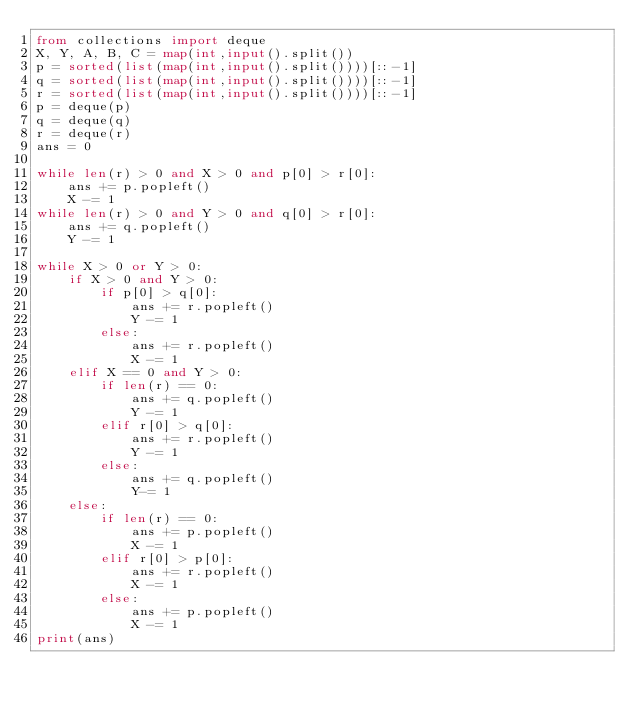Convert code to text. <code><loc_0><loc_0><loc_500><loc_500><_Python_>from collections import deque
X, Y, A, B, C = map(int,input().split())
p = sorted(list(map(int,input().split())))[::-1]
q = sorted(list(map(int,input().split())))[::-1]
r = sorted(list(map(int,input().split())))[::-1]
p = deque(p)
q = deque(q)
r = deque(r)
ans = 0

while len(r) > 0 and X > 0 and p[0] > r[0]:
    ans += p.popleft()
    X -= 1
while len(r) > 0 and Y > 0 and q[0] > r[0]:
    ans += q.popleft()
    Y -= 1

while X > 0 or Y > 0:
    if X > 0 and Y > 0:
        if p[0] > q[0]:
            ans += r.popleft()
            Y -= 1
        else:
            ans += r.popleft()
            X -= 1
    elif X == 0 and Y > 0:
        if len(r) == 0:
            ans += q.popleft()
            Y -= 1
        elif r[0] > q[0]:
            ans += r.popleft()
            Y -= 1
        else:
            ans += q.popleft()
            Y-= 1
    else:
        if len(r) == 0:
            ans += p.popleft()
            X -= 1
        elif r[0] > p[0]:
            ans += r.popleft()
            X -= 1
        else:
            ans += p.popleft()
            X -= 1
print(ans)
</code> 